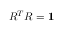Convert formula to latex. <formula><loc_0><loc_0><loc_500><loc_500>R ^ { T } R = { 1 }</formula> 